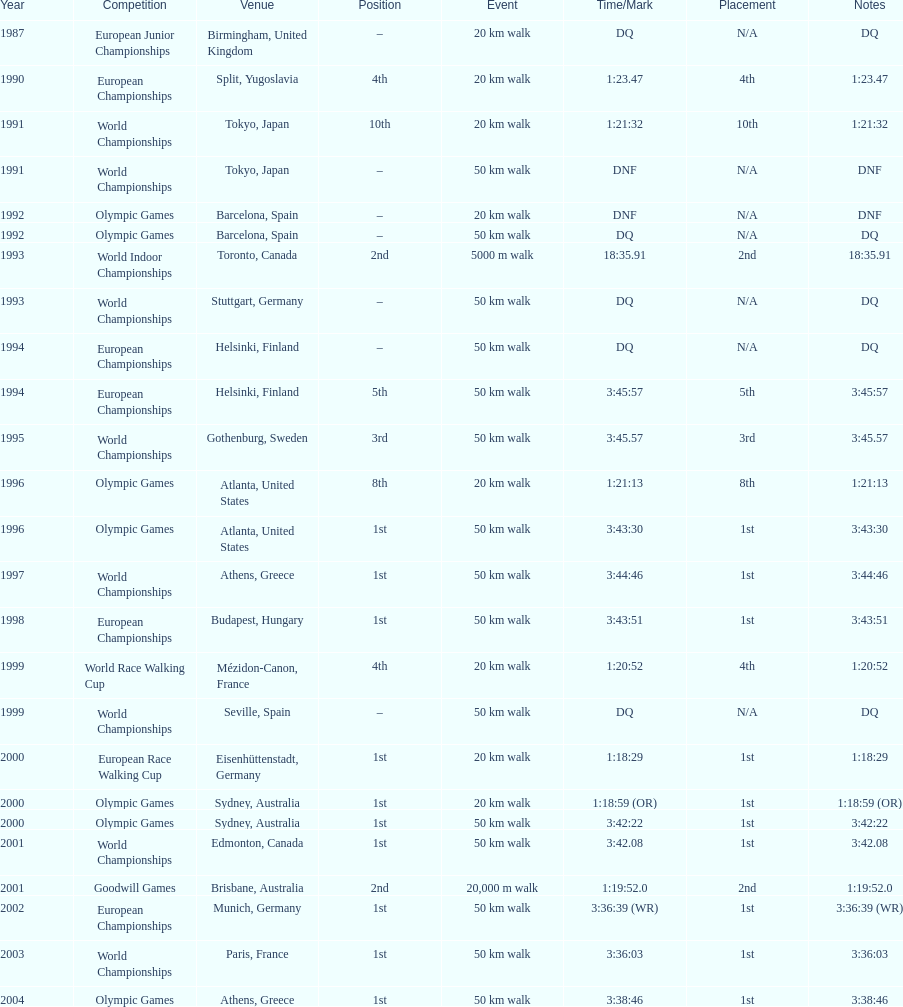Help me parse the entirety of this table. {'header': ['Year', 'Competition', 'Venue', 'Position', 'Event', 'Time/Mark', 'Placement', 'Notes'], 'rows': [['1987', 'European Junior Championships', 'Birmingham, United Kingdom', '–', '20\xa0km walk', 'DQ', 'N/A', 'DQ'], ['1990', 'European Championships', 'Split, Yugoslavia', '4th', '20\xa0km walk', '1:23.47', '4th', '1:23.47'], ['1991', 'World Championships', 'Tokyo, Japan', '10th', '20\xa0km walk', '1:21:32', '10th', '1:21:32'], ['1991', 'World Championships', 'Tokyo, Japan', '–', '50\xa0km walk', 'DNF', 'N/A', 'DNF'], ['1992', 'Olympic Games', 'Barcelona, Spain', '–', '20\xa0km walk', 'DNF', 'N/A', 'DNF'], ['1992', 'Olympic Games', 'Barcelona, Spain', '–', '50\xa0km walk', 'DQ', 'N/A', 'DQ'], ['1993', 'World Indoor Championships', 'Toronto, Canada', '2nd', '5000 m walk', '18:35.91', '2nd', '18:35.91'], ['1993', 'World Championships', 'Stuttgart, Germany', '–', '50\xa0km walk', 'DQ', 'N/A', 'DQ'], ['1994', 'European Championships', 'Helsinki, Finland', '–', '50\xa0km walk', 'DQ', 'N/A', 'DQ'], ['1994', 'European Championships', 'Helsinki, Finland', '5th', '50\xa0km walk', '3:45:57', '5th', '3:45:57'], ['1995', 'World Championships', 'Gothenburg, Sweden', '3rd', '50\xa0km walk', '3:45.57', '3rd', '3:45.57'], ['1996', 'Olympic Games', 'Atlanta, United States', '8th', '20\xa0km walk', '1:21:13', '8th', '1:21:13'], ['1996', 'Olympic Games', 'Atlanta, United States', '1st', '50\xa0km walk', '3:43:30', '1st', '3:43:30'], ['1997', 'World Championships', 'Athens, Greece', '1st', '50\xa0km walk', '3:44:46', '1st', '3:44:46'], ['1998', 'European Championships', 'Budapest, Hungary', '1st', '50\xa0km walk', '3:43:51', '1st', '3:43:51'], ['1999', 'World Race Walking Cup', 'Mézidon-Canon, France', '4th', '20\xa0km walk', '1:20:52', '4th', '1:20:52'], ['1999', 'World Championships', 'Seville, Spain', '–', '50\xa0km walk', 'DQ', 'N/A', 'DQ'], ['2000', 'European Race Walking Cup', 'Eisenhüttenstadt, Germany', '1st', '20\xa0km walk', '1:18:29', '1st', '1:18:29'], ['2000', 'Olympic Games', 'Sydney, Australia', '1st', '20\xa0km walk', '1:18:59 (OR)', '1st', '1:18:59 (OR)'], ['2000', 'Olympic Games', 'Sydney, Australia', '1st', '50\xa0km walk', '3:42:22', '1st', '3:42:22'], ['2001', 'World Championships', 'Edmonton, Canada', '1st', '50\xa0km walk', '3:42.08', '1st', '3:42.08'], ['2001', 'Goodwill Games', 'Brisbane, Australia', '2nd', '20,000 m walk', '1:19:52.0', '2nd', '1:19:52.0'], ['2002', 'European Championships', 'Munich, Germany', '1st', '50\xa0km walk', '3:36:39 (WR)', '1st', '3:36:39 (WR)'], ['2003', 'World Championships', 'Paris, France', '1st', '50\xa0km walk', '3:36:03', '1st', '3:36:03'], ['2004', 'Olympic Games', 'Athens, Greece', '1st', '50\xa0km walk', '3:38:46', '1st', '3:38:46']]} How long did it take to walk 50 km in the 2004 olympic games? 3:38:46. 